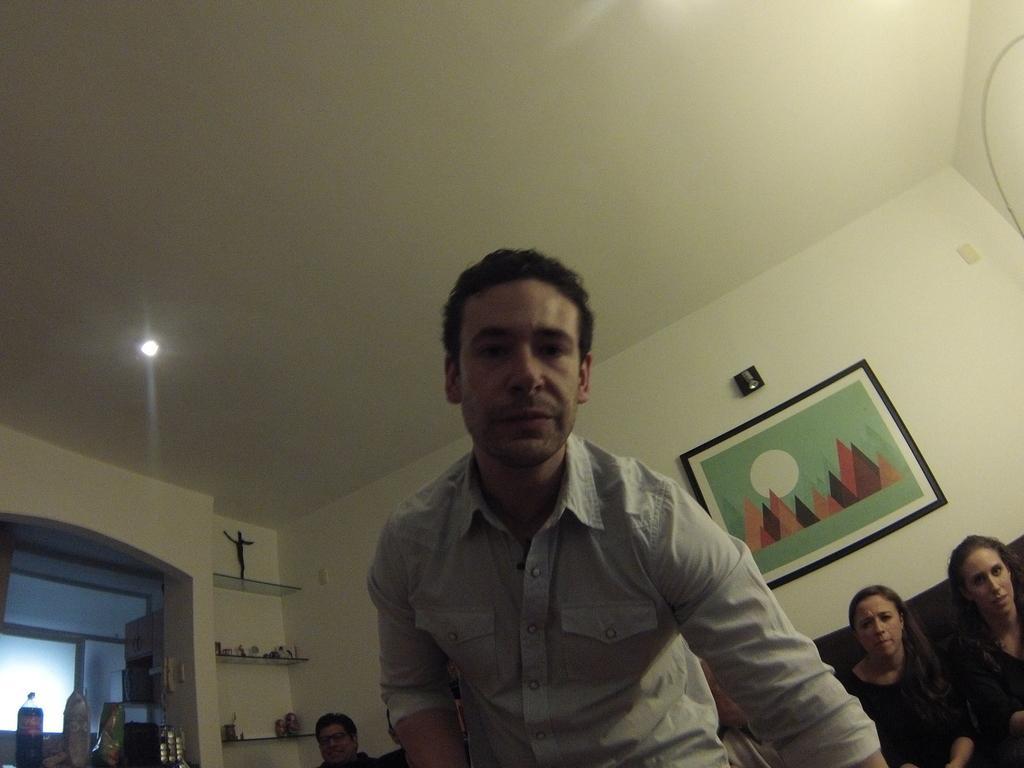Can you describe this image briefly? This picture shows few people seated and a man standing and we see photo frame on the wall and a roof light and we see couple of bottles and toys in the shelf,. 